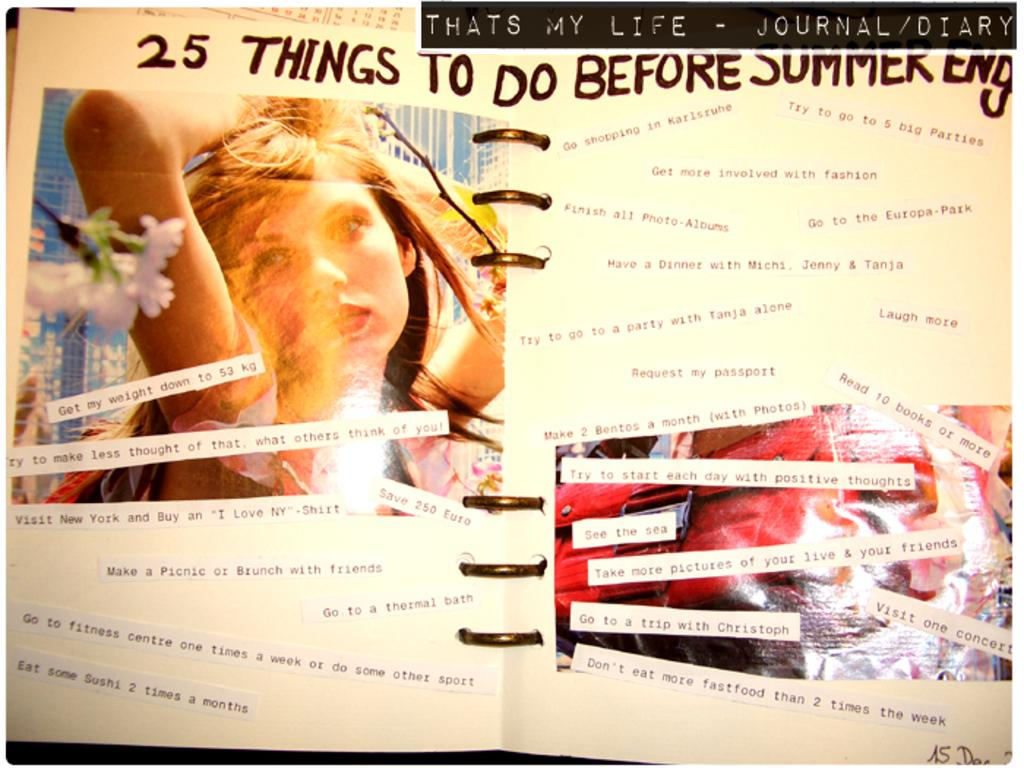What is the main object in the image? There is a book in the image. How is the book decorated? The book has various things pasted on it. What type of binding does the book have? The book has a spiral binding. Can you describe the image on the book? There is a picture of a woman on the left side of the book. What type of insurance policy is mentioned on the book? There is no mention of insurance in the image; it features a book with various things pasted on it and a picture of a woman. Can you tell me how the knife is used in the image? There is no knife present in the image. 